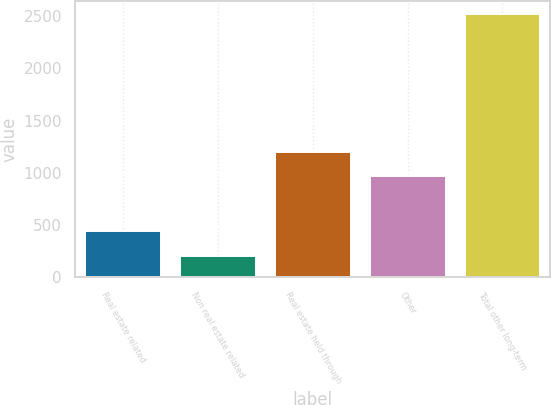Convert chart. <chart><loc_0><loc_0><loc_500><loc_500><bar_chart><fcel>Real estate related<fcel>Non real estate related<fcel>Real estate held through<fcel>Other<fcel>Total other long-term<nl><fcel>439<fcel>208<fcel>1200<fcel>969<fcel>2518<nl></chart> 